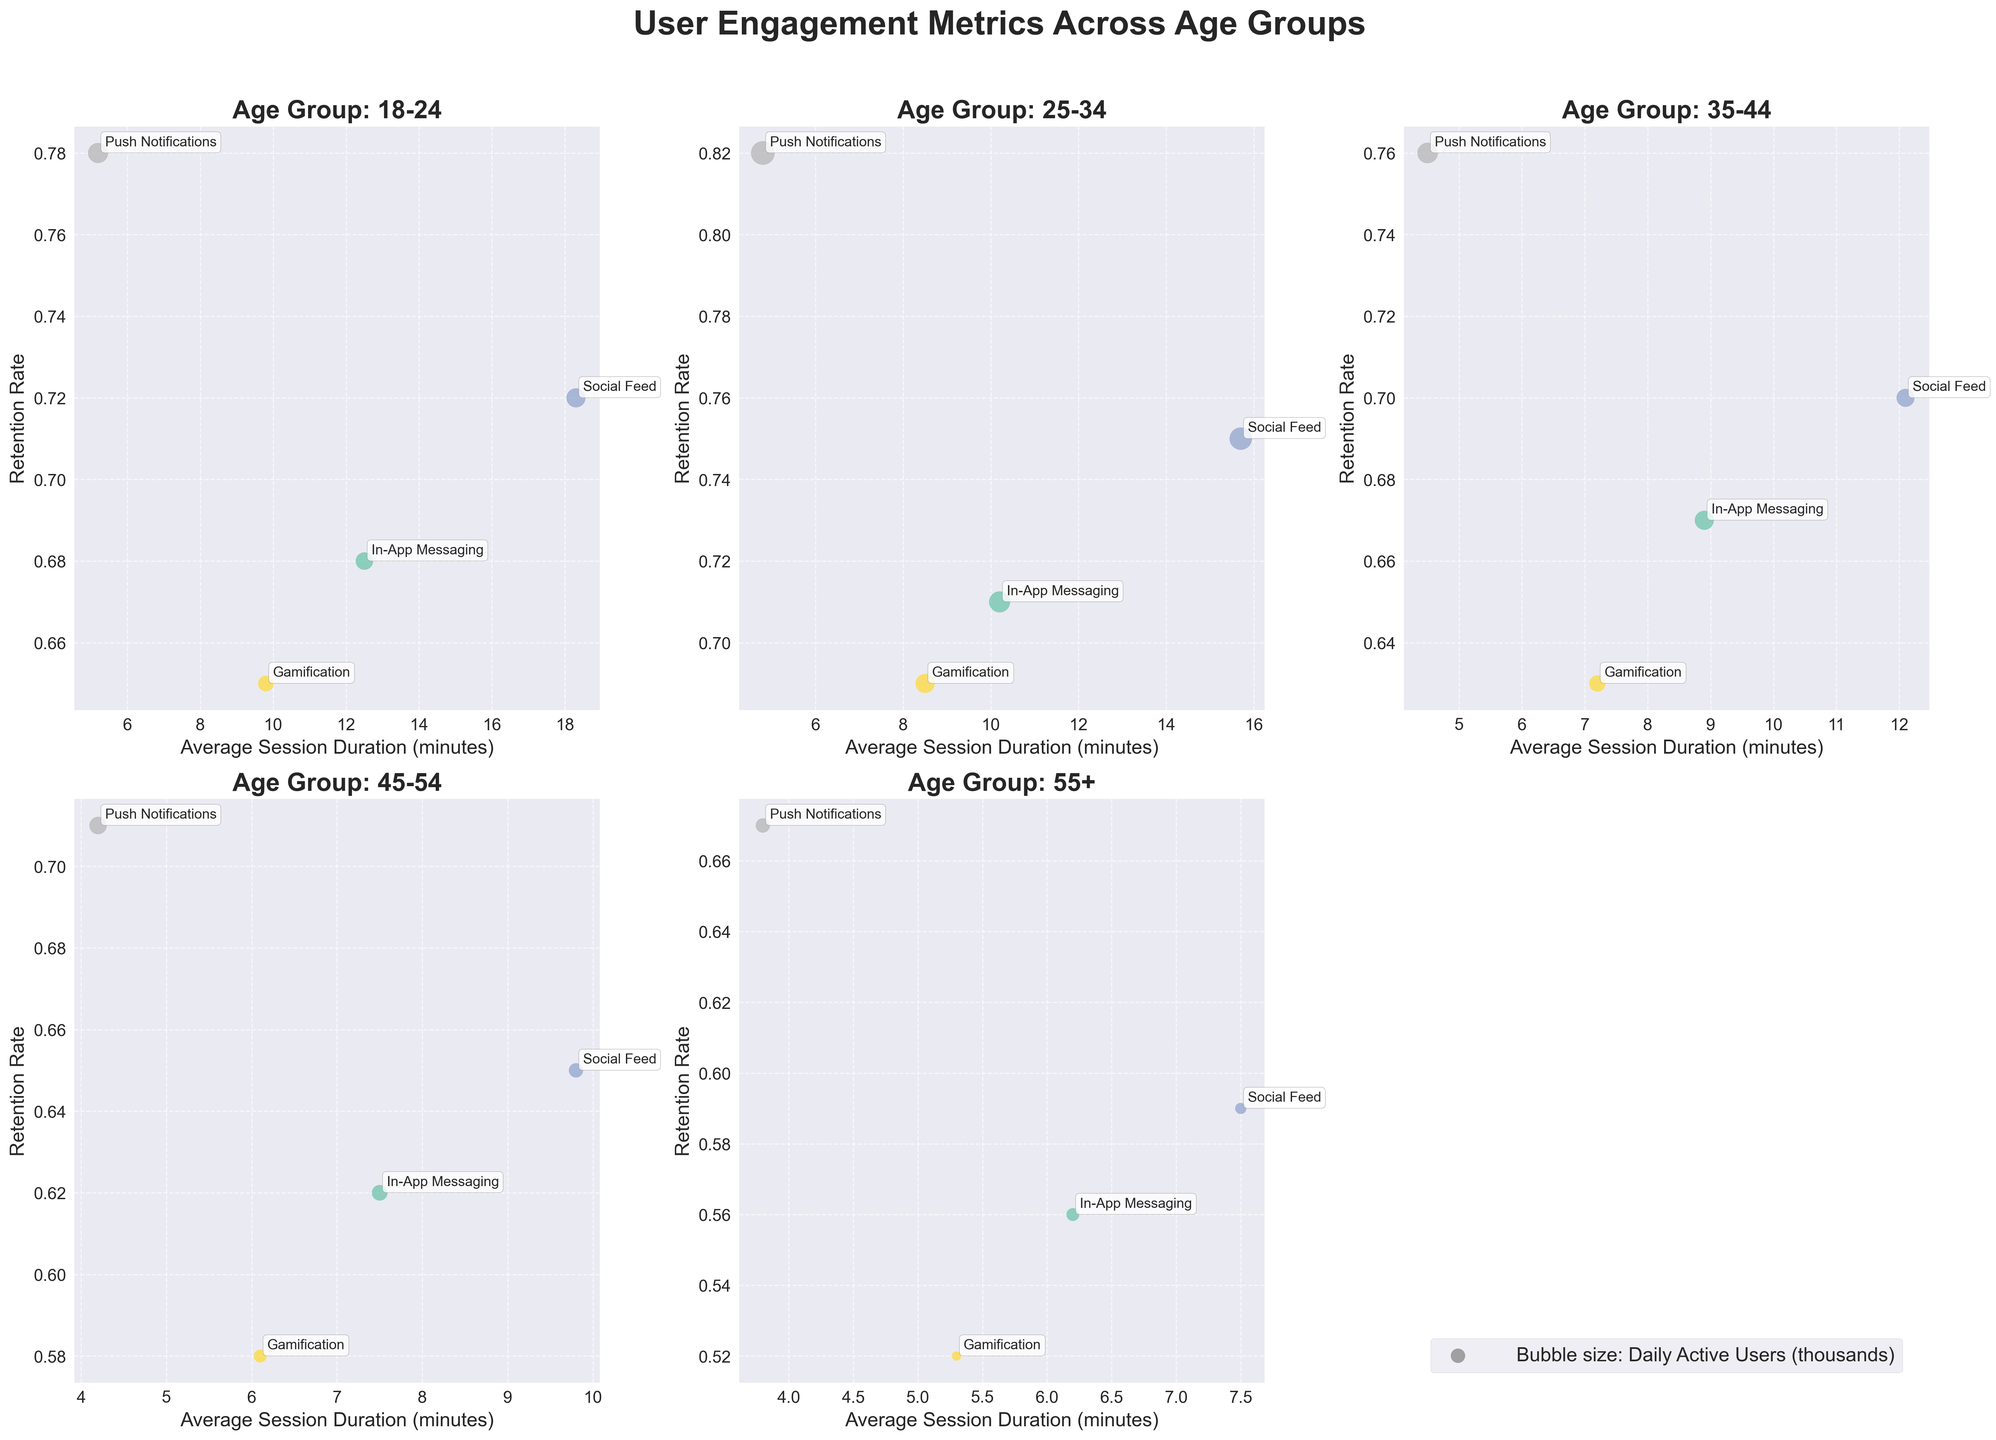How many age groups are represented in the figure? There are five separate subplots in the figure, each representing a different age group. By checking the titles of the subplots, we can see the distinct age groups listed.
Answer: Five Which feature has the largest bubble size for the age group 25-34? The bubble size represents Daily Active Users. In the subplot for the age group 25-34, the largest bubble corresponds to the feature with the highest Daily Active Users count. By inspecting the sizes, we can see that 'Push Notifications' has the largest bubble.
Answer: Push Notifications What is the retention rate for 'Gamification' in the age group 35-44? To find the retention rate for 'Gamification' in the subplot for the age group 35-44, look at the specific bubble labeled 'Gamification' and note its position on the y-axis, which represents the retention rate. The retention rate is found to be 0.63.
Answer: 0.63 Which feature has the shortest average session duration in the age group 45-54? By looking at the x-axis of the subplot for the age group 45-54, we can find the feature bubble that is positioned furthest to the left, indicating the shortest average session duration. 'Push Notifications' has the shortest duration on the x-axis.
Answer: Push Notifications How does the average session duration for 'Social Feed' compare between the age groups 18-24 and 55+? Compare the x-axis positions of the 'Social Feed' bubbles in the subplots for age groups 18-24 and 55+. The average session durations can be read off the x-axis. For 18-24, it's 18.3 minutes, and for 55+, it's 7.5 minutes, indicating that 18-24 has a longer average session duration.
Answer: 18-24 is longer Which age group has the highest retention rate for 'In-App Messaging' and what is this rate? Observe the y-axis positions of the 'In-App Messaging' bubbles across all subplots. The highest retention rate is identified by the highest position on the y-axis. The age group 25-34 has the highest retention rate at 0.71.
Answer: 25-34, 0.71 What's the difference between the Daily Active Users for 'Push Notifications' in the age groups 25-34 and 18-24? Note the bubble sizes of the 'Push Notifications' feature in the subplots for age groups 25-34 (280,000) and 18-24 (200,000). The difference is calculated by subtracting the smaller value from the larger value (280,000 - 200,000).
Answer: 80,000 Which age group has the smallest size bubble for 'Gamification'? To find the smallest bubble size for 'Gamification', we compare the sizes of the 'Gamification' bubbles across all age groups. The smallest size, which represents Daily Active Users, appears for the age group 55+.
Answer: 55+ What is the relationship between average session duration and retention rate for 'Social Feed' in the age group 35-44? In the subplot for 35-44, check the 'Social Feed' bubble and see its x-axis (average session duration) and y-axis (retention rate) coordinates. Average session duration is 12.1 minutes and retention rate is 0.70, showing that as average session duration increases, retention rate is moderately high.
Answer: Average session duration: 12.1, Retention rate: 0.70 Is there any feature in the age group 55+ with a retention rate above 0.65? Check the y-axis positions of all the bubbles in the subplot for the age group 55+. Only the 'Push Notifications' bubble exceeds the 0.65 mark on the retention rate axis.
Answer: Yes, Push Notifications 